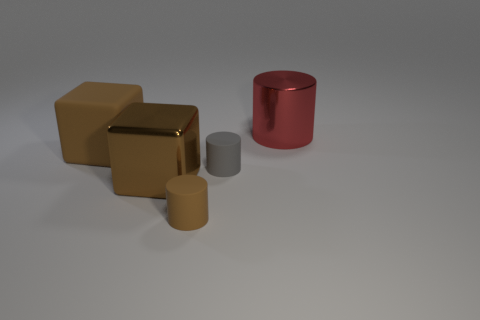What size is the metal object that is the same shape as the gray rubber thing?
Offer a very short reply. Large. Is the number of large metal objects greater than the number of gray cylinders?
Offer a very short reply. Yes. Do the gray object and the red shiny object have the same shape?
Offer a terse response. Yes. What is the material of the big block right of the big brown block that is behind the large brown metal object?
Keep it short and to the point. Metal. There is another large block that is the same color as the rubber block; what is its material?
Your response must be concise. Metal. Do the gray matte cylinder and the red metallic cylinder have the same size?
Keep it short and to the point. No. There is a big metallic thing left of the big cylinder; are there any brown things that are on the left side of it?
Your response must be concise. Yes. There is a metallic object that is the same color as the big matte cube; what is its size?
Offer a terse response. Large. What is the shape of the matte object behind the small gray object?
Provide a succinct answer. Cube. How many large brown blocks are in front of the small matte object that is to the right of the tiny thing in front of the large brown metallic object?
Offer a terse response. 1. 